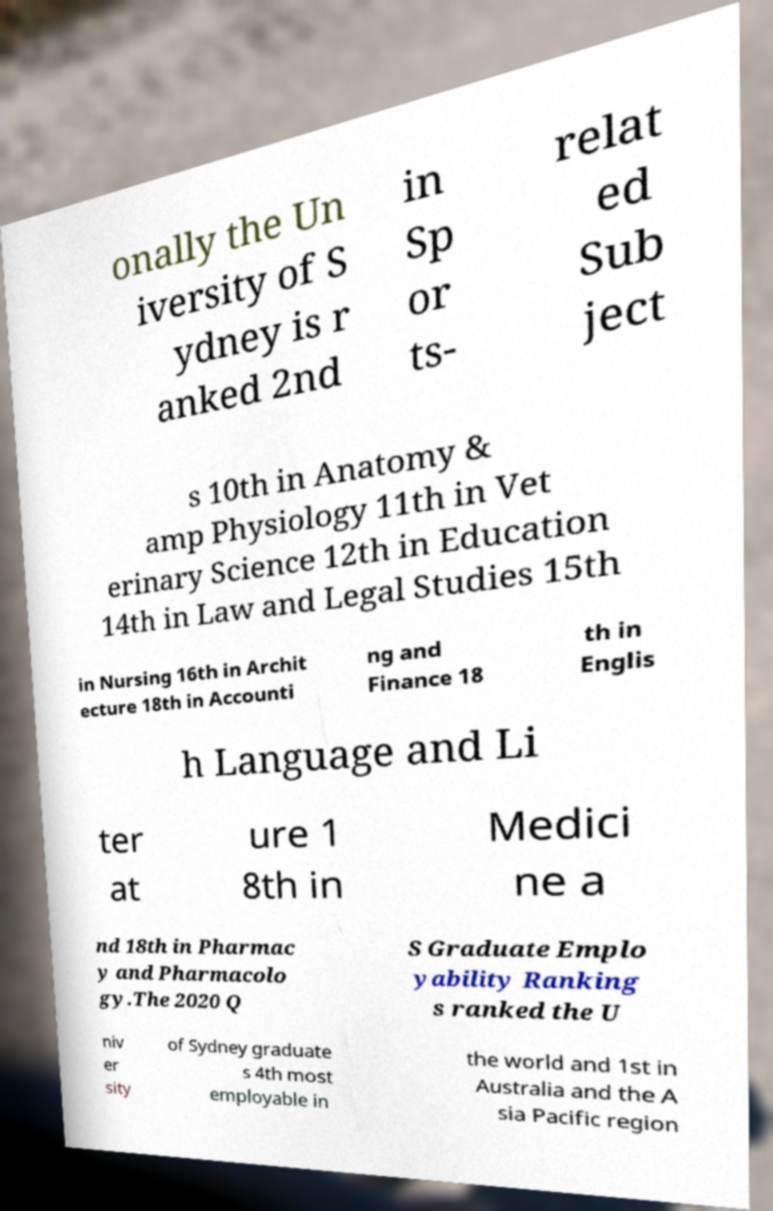There's text embedded in this image that I need extracted. Can you transcribe it verbatim? onally the Un iversity of S ydney is r anked 2nd in Sp or ts- relat ed Sub ject s 10th in Anatomy & amp Physiology 11th in Vet erinary Science 12th in Education 14th in Law and Legal Studies 15th in Nursing 16th in Archit ecture 18th in Accounti ng and Finance 18 th in Englis h Language and Li ter at ure 1 8th in Medici ne a nd 18th in Pharmac y and Pharmacolo gy.The 2020 Q S Graduate Emplo yability Ranking s ranked the U niv er sity of Sydney graduate s 4th most employable in the world and 1st in Australia and the A sia Pacific region 